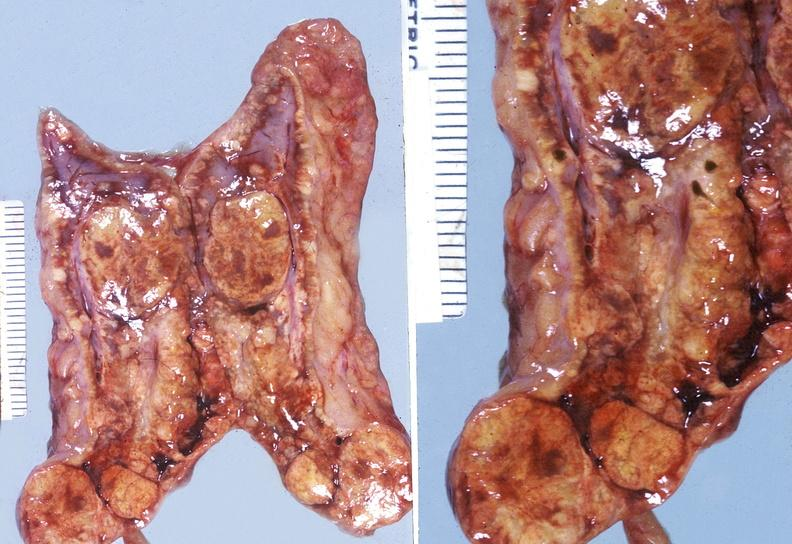does metastatic carcinoma prostate show adrenal, cortical adenoma?
Answer the question using a single word or phrase. No 